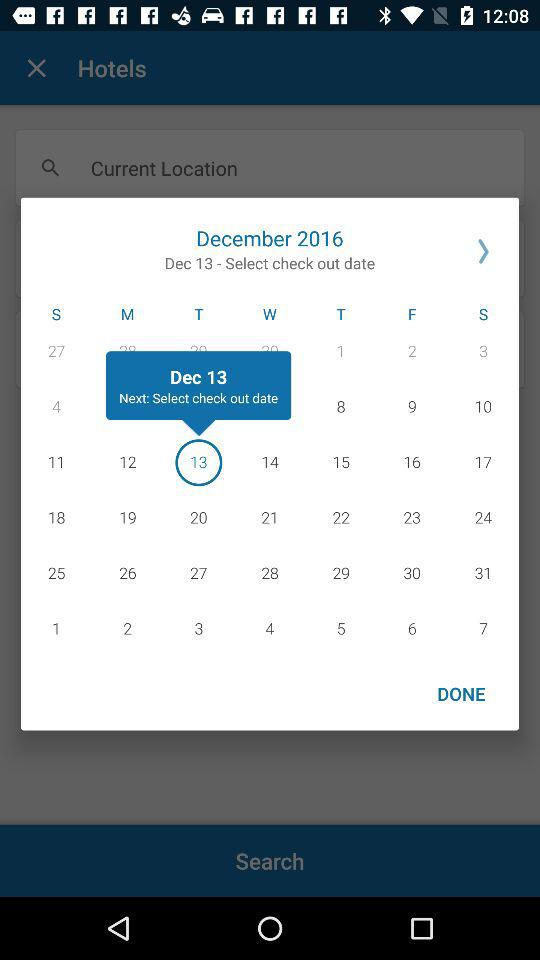Which month and year are selected? The selected month is December and the year is 2016. 